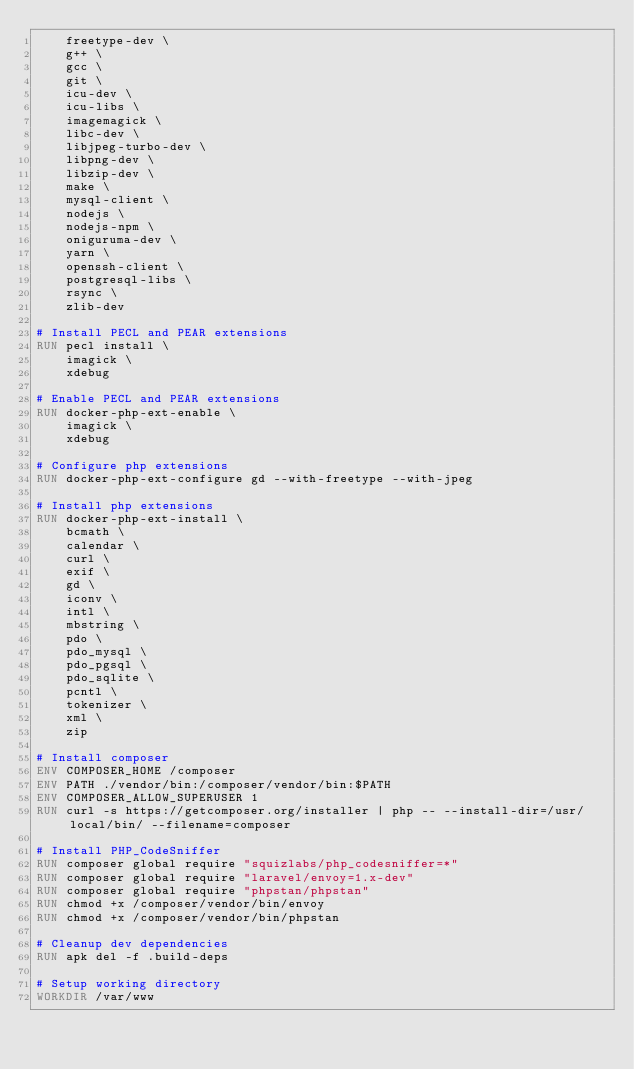Convert code to text. <code><loc_0><loc_0><loc_500><loc_500><_Dockerfile_>    freetype-dev \
    g++ \
    gcc \
    git \
    icu-dev \
    icu-libs \
    imagemagick \
    libc-dev \
    libjpeg-turbo-dev \
    libpng-dev \
    libzip-dev \
    make \
    mysql-client \
    nodejs \
    nodejs-npm \
    oniguruma-dev \
    yarn \
    openssh-client \
    postgresql-libs \
    rsync \
    zlib-dev

# Install PECL and PEAR extensions
RUN pecl install \
    imagick \
    xdebug

# Enable PECL and PEAR extensions
RUN docker-php-ext-enable \
    imagick \
    xdebug

# Configure php extensions
RUN docker-php-ext-configure gd --with-freetype --with-jpeg

# Install php extensions
RUN docker-php-ext-install \
    bcmath \
    calendar \
    curl \
    exif \
    gd \
    iconv \
    intl \
    mbstring \
    pdo \
    pdo_mysql \
    pdo_pgsql \
    pdo_sqlite \
    pcntl \
    tokenizer \
    xml \
    zip

# Install composer
ENV COMPOSER_HOME /composer
ENV PATH ./vendor/bin:/composer/vendor/bin:$PATH
ENV COMPOSER_ALLOW_SUPERUSER 1
RUN curl -s https://getcomposer.org/installer | php -- --install-dir=/usr/local/bin/ --filename=composer

# Install PHP_CodeSniffer
RUN composer global require "squizlabs/php_codesniffer=*"
RUN composer global require "laravel/envoy=1.x-dev"
RUN composer global require "phpstan/phpstan"
RUN chmod +x /composer/vendor/bin/envoy
RUN chmod +x /composer/vendor/bin/phpstan

# Cleanup dev dependencies
RUN apk del -f .build-deps

# Setup working directory
WORKDIR /var/www
</code> 